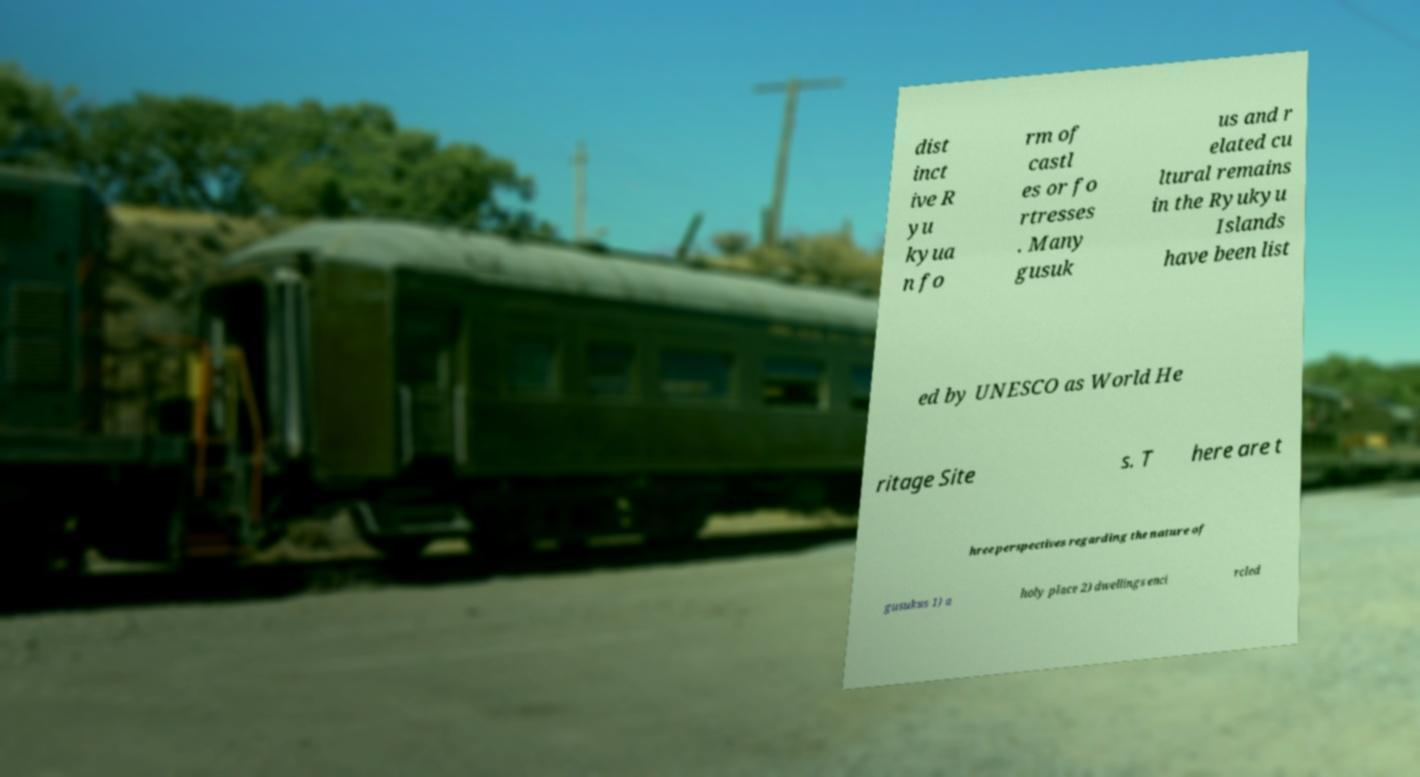Could you assist in decoding the text presented in this image and type it out clearly? dist inct ive R yu kyua n fo rm of castl es or fo rtresses . Many gusuk us and r elated cu ltural remains in the Ryukyu Islands have been list ed by UNESCO as World He ritage Site s. T here are t hree perspectives regarding the nature of gusukus 1) a holy place 2) dwellings enci rcled 